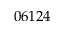Convert formula to latex. <formula><loc_0><loc_0><loc_500><loc_500>0 6 1 2 4</formula> 